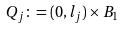<formula> <loc_0><loc_0><loc_500><loc_500>Q _ { j } \colon = ( 0 , l _ { j } ) \times B _ { 1 }</formula> 